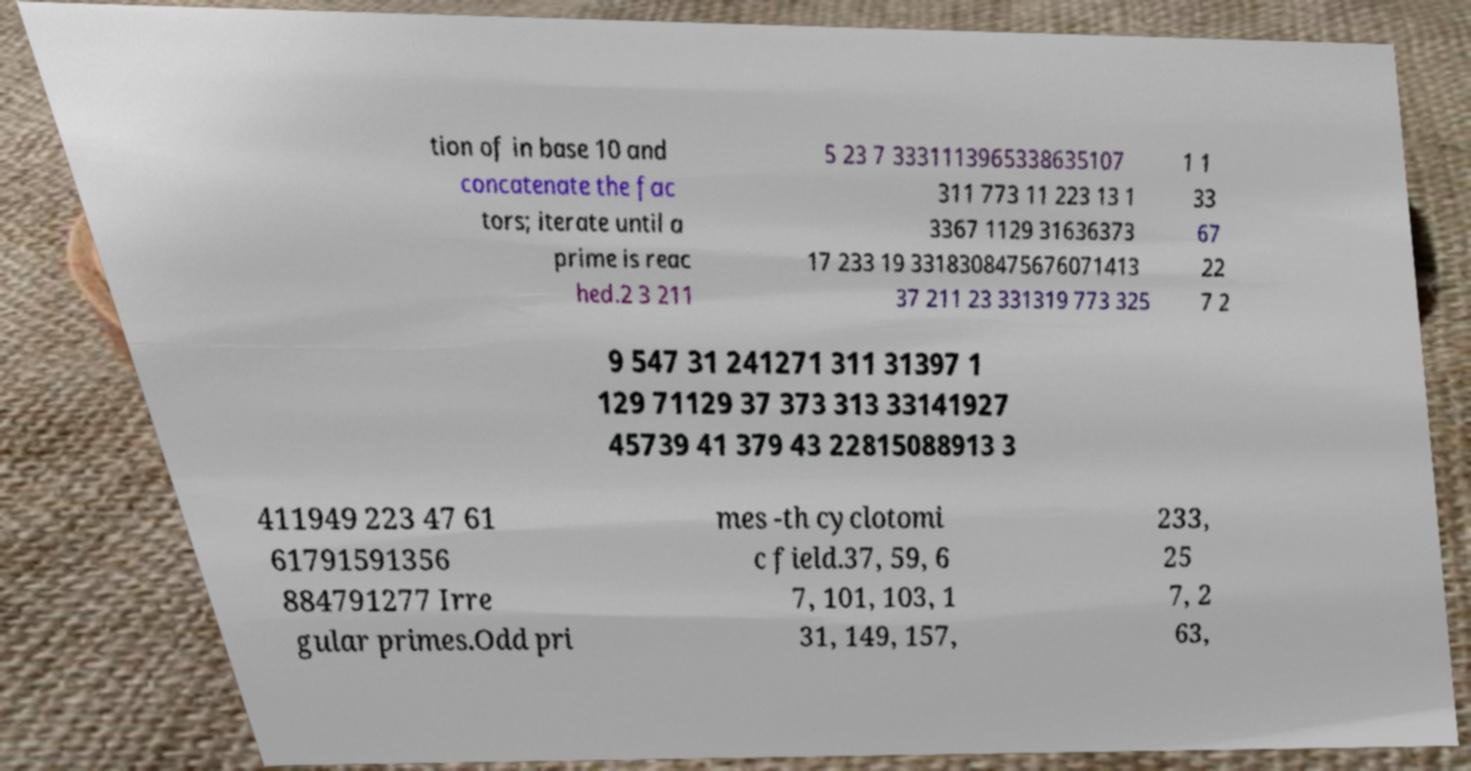Can you accurately transcribe the text from the provided image for me? tion of in base 10 and concatenate the fac tors; iterate until a prime is reac hed.2 3 211 5 23 7 3331113965338635107 311 773 11 223 13 1 3367 1129 31636373 17 233 19 3318308475676071413 37 211 23 331319 773 325 1 1 33 67 22 7 2 9 547 31 241271 311 31397 1 129 71129 37 373 313 33141927 45739 41 379 43 22815088913 3 411949 223 47 61 61791591356 884791277 Irre gular primes.Odd pri mes -th cyclotomi c field.37, 59, 6 7, 101, 103, 1 31, 149, 157, 233, 25 7, 2 63, 